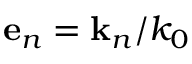Convert formula to latex. <formula><loc_0><loc_0><loc_500><loc_500>e _ { n } = k _ { n } / k _ { 0 }</formula> 